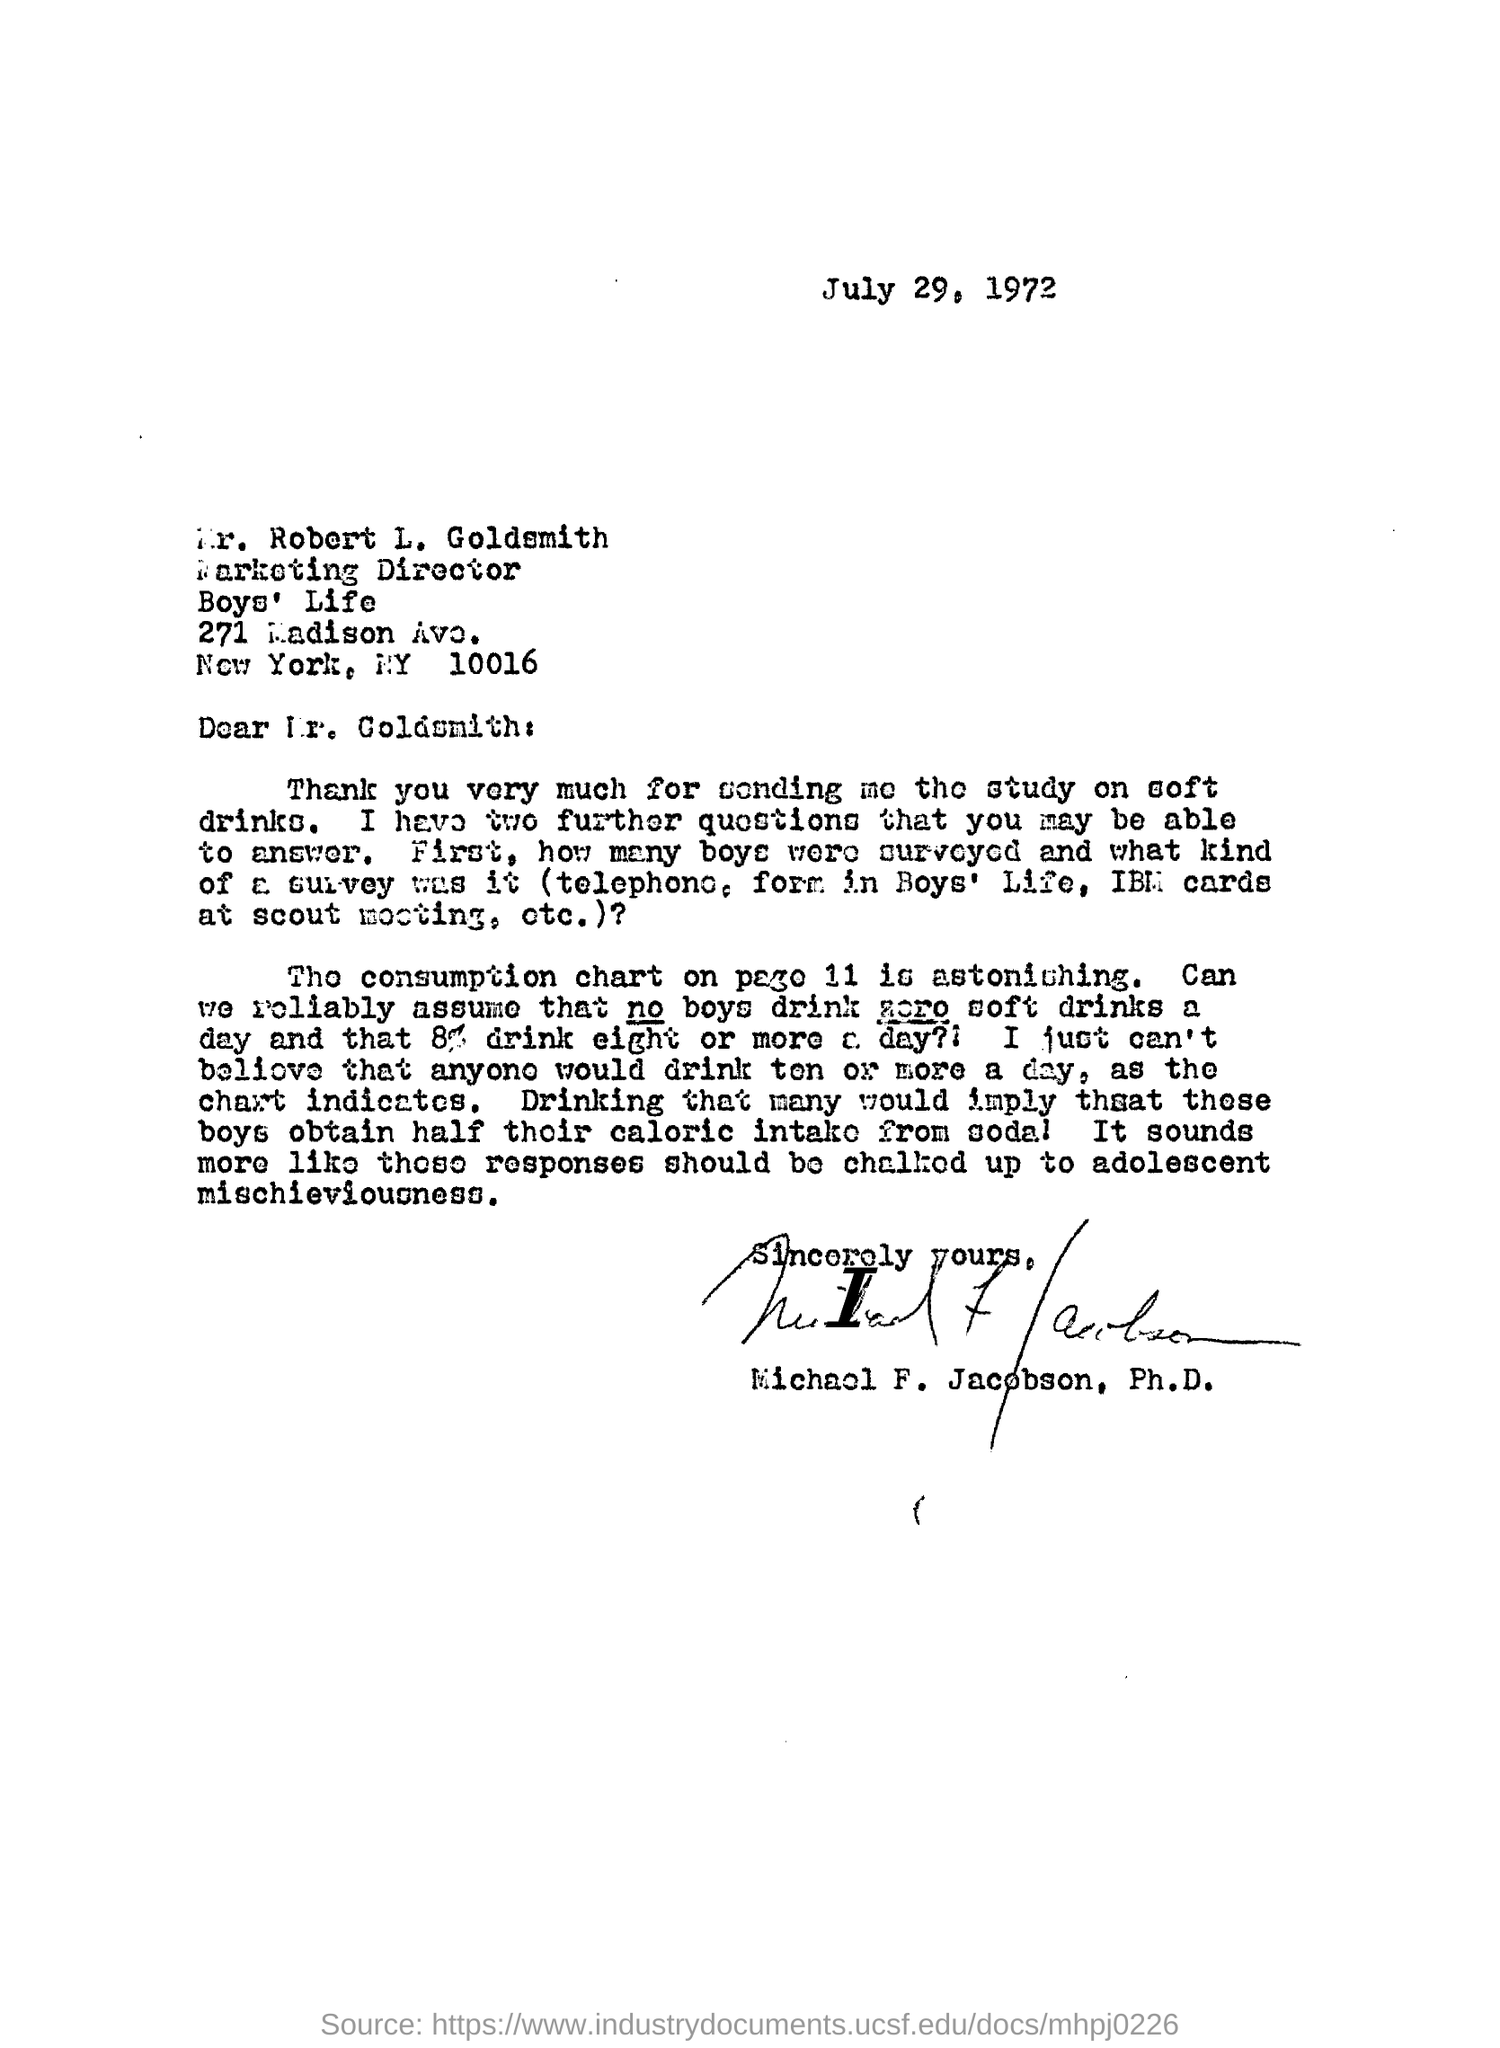What kind of study is mentioned in this letter?
Your response must be concise. Study on soft drinks. What is the date mentioned on the top of the letter ?
Offer a terse response. July 29, 1972. What is the date of this letter?
Make the answer very short. July 29,  1972. 